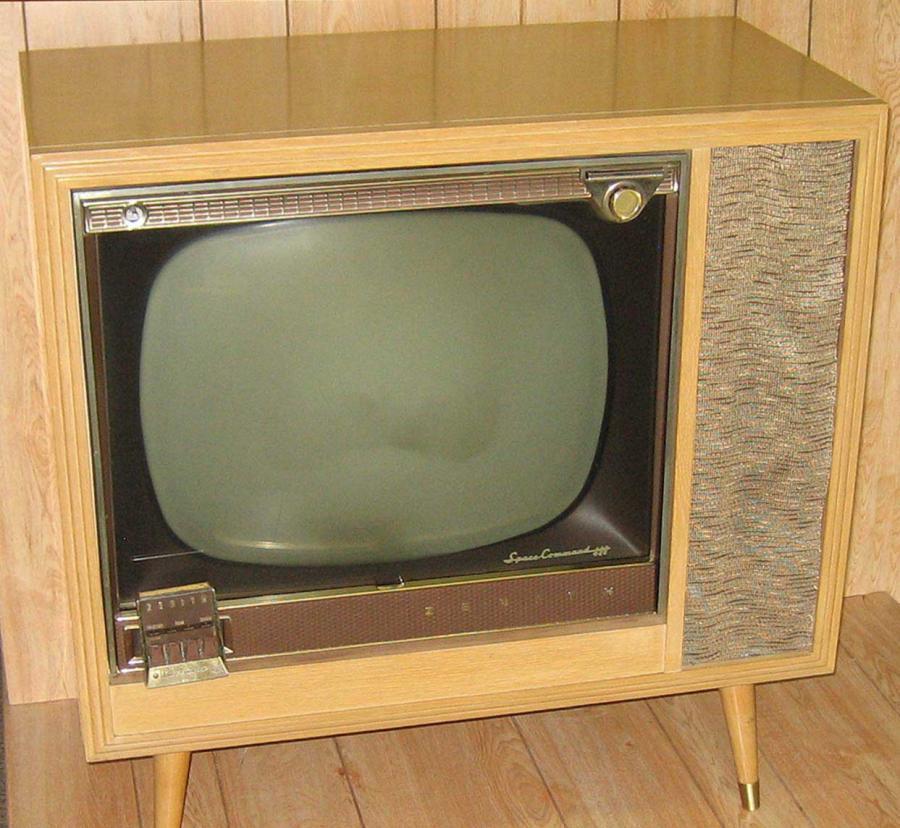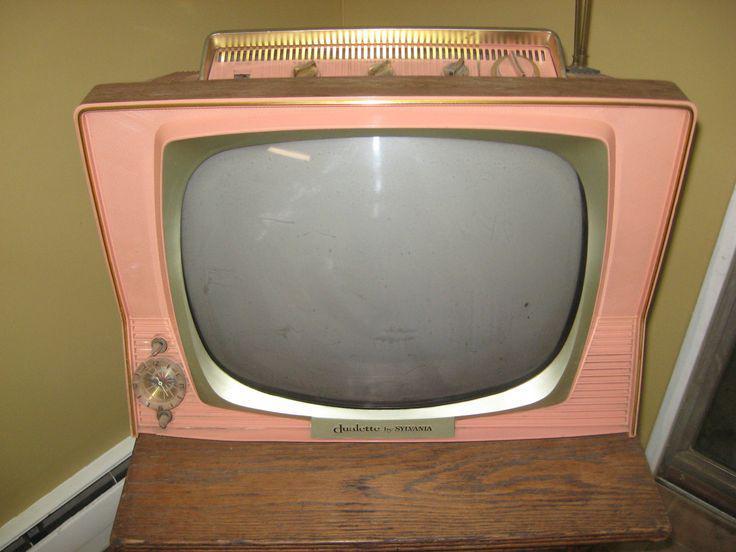The first image is the image on the left, the second image is the image on the right. Examine the images to the left and right. Is the description "Two televisions are shown, one a tabletop model, and the other in a wooden console cabinet on legs." accurate? Answer yes or no. Yes. 